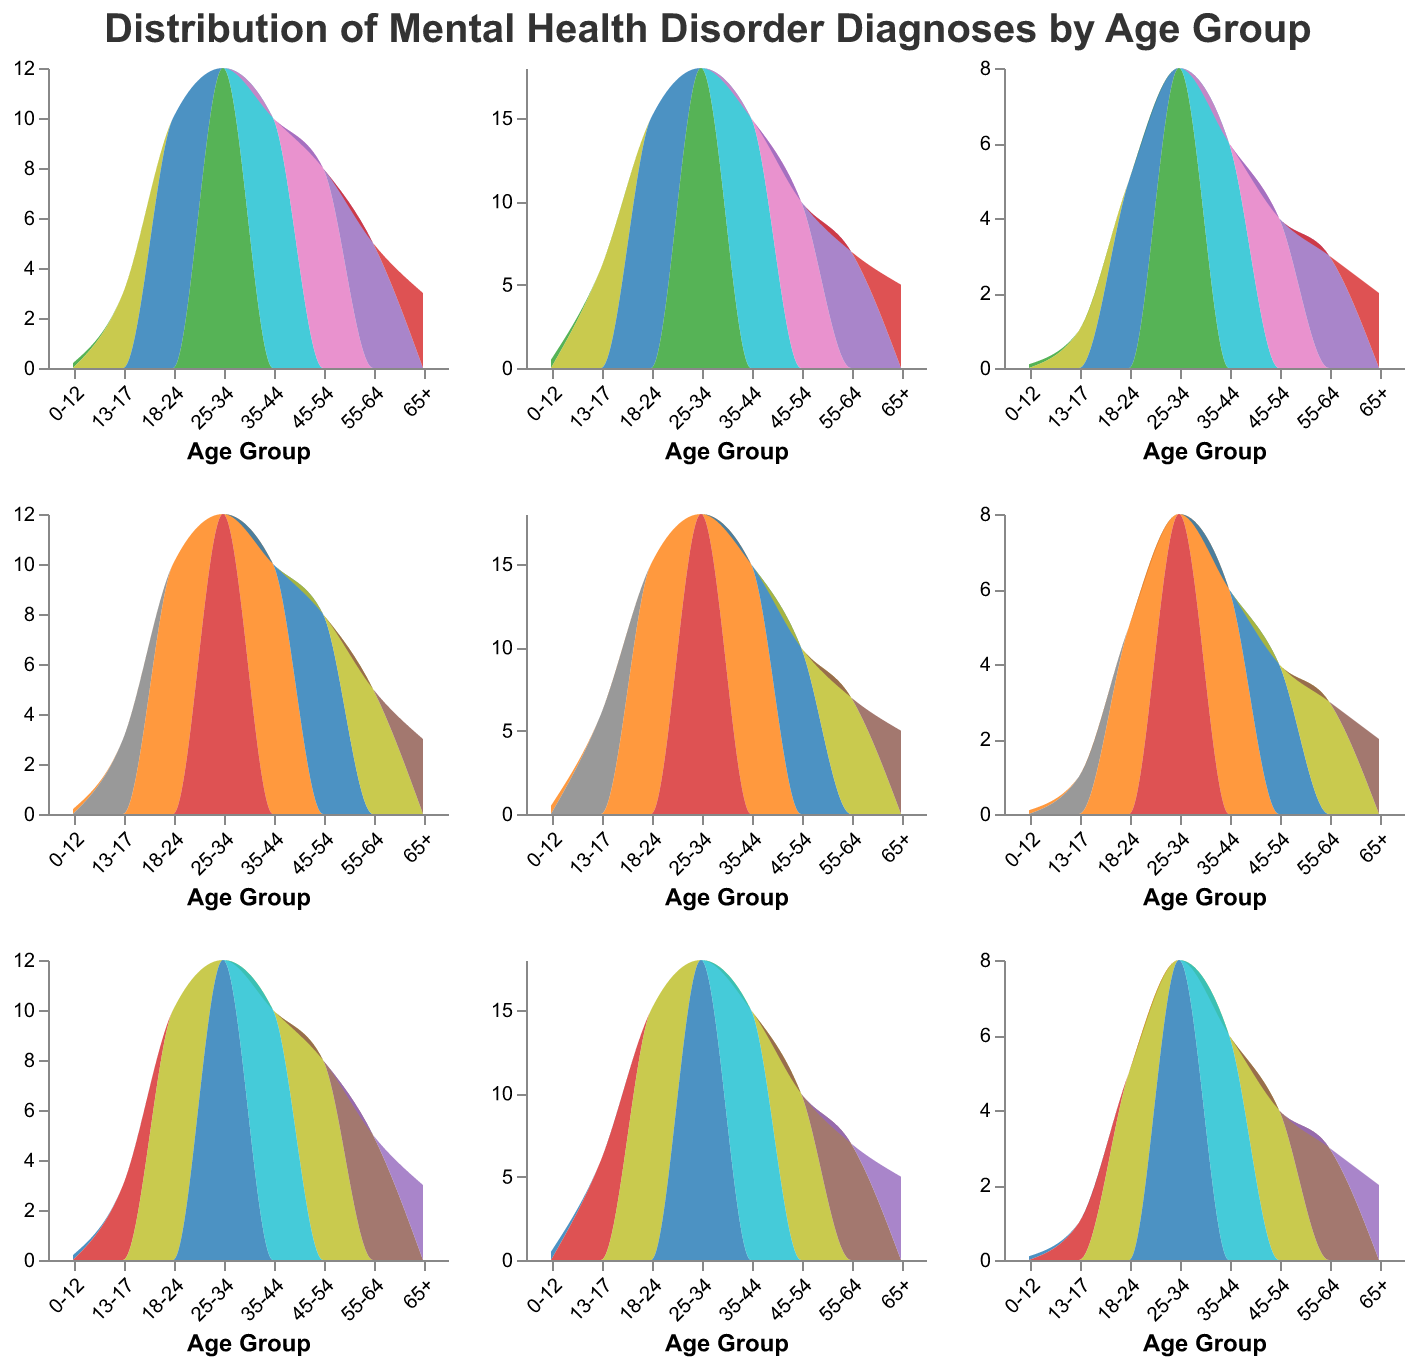Which age group has the highest rate of PTSD diagnoses? By looking at the PTSD subplot, we see that the highest area peak for PTSD occurs in the age group 25-34.
Answer: 25-34 How does the rate of Anxiety Disorders in the age group 25-34 compare to that in the 0-12 group? In the Anxiety Disorders subplot, the height of the area for the 25-34 age group is significantly higher than for the 0-12 age group. Specifically, the rate is 25 for 25-34 and 2 for 0-12.
Answer: 25-34 is higher Which disorder shows a decrease in diagnoses after the age group 25-34? The necessary operation is to look at each subplot and identify trends. Both Anxiety Disorders and Substance Use Disorders show a decline after the 25-34 age group.
Answer: Anxiety and Substance Use Disorders In which age group do Depressive Disorders transition to double digits? Observing the Depressive Disorders subplot, double digits first appear in the age group 13-17.
Answer: 13-17 Compare the diagnoses of Schizophrenia between the age groups 18-24 and 45-54. In the Schizophrenia subplot, the height of the area for age group 18-24 is measured at 5, while for the age group 45-54, it is 4.
Answer: 18-24 has more Which disorder shows a peak twice in the age distribution? By reviewing each subplot in the multiple area charts, Depressive Disorders exhibit peaks both in the 25-34 and 35-44 age groups.
Answer: Depressive Disorders How many disorders have a diagnosis rate of zero in the age group 0-12? Inspecting each subplot at the 0-12 age group, only Substance Use Disorders show a rate close to zero.
Answer: One Which age group has the lowest rate of diagnoses for Personality Disorders? Looking at the Personality Disorders subplot, the 0-12 age group has the lowest rate, marked at 0.2.
Answer: 0-12 What trend is observed in Schizophrenia diagnoses as age increases after 25-34? The Schizophrenia subplot shows that after peaking at 25-34, the rate decreases steadily through the older age groups.
Answer: Decreasing trend 